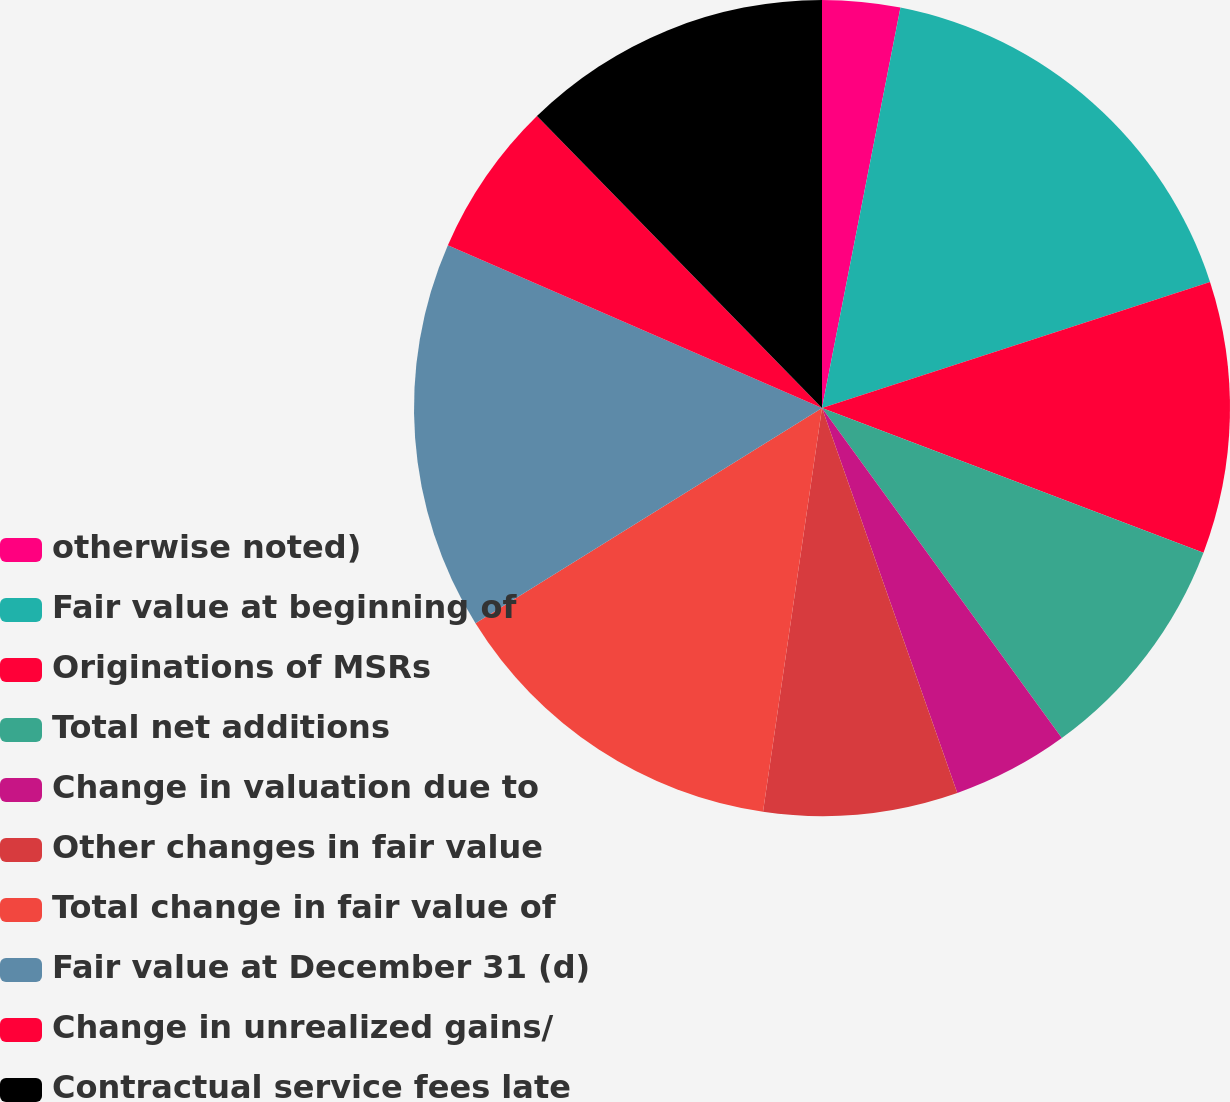<chart> <loc_0><loc_0><loc_500><loc_500><pie_chart><fcel>otherwise noted)<fcel>Fair value at beginning of<fcel>Originations of MSRs<fcel>Total net additions<fcel>Change in valuation due to<fcel>Other changes in fair value<fcel>Total change in fair value of<fcel>Fair value at December 31 (d)<fcel>Change in unrealized gains/<fcel>Contractual service fees late<nl><fcel>3.08%<fcel>16.92%<fcel>10.77%<fcel>9.23%<fcel>4.62%<fcel>7.69%<fcel>13.84%<fcel>15.38%<fcel>6.16%<fcel>12.31%<nl></chart> 